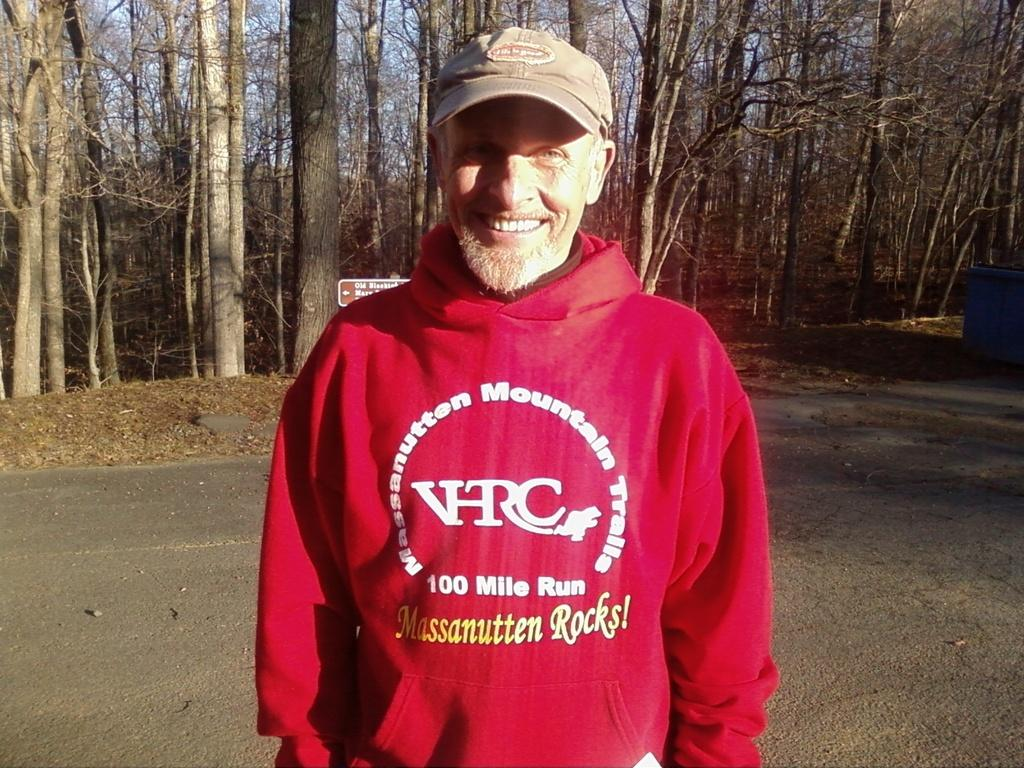<image>
Provide a brief description of the given image. a man in a red sweater with a 100 mile run written on it 